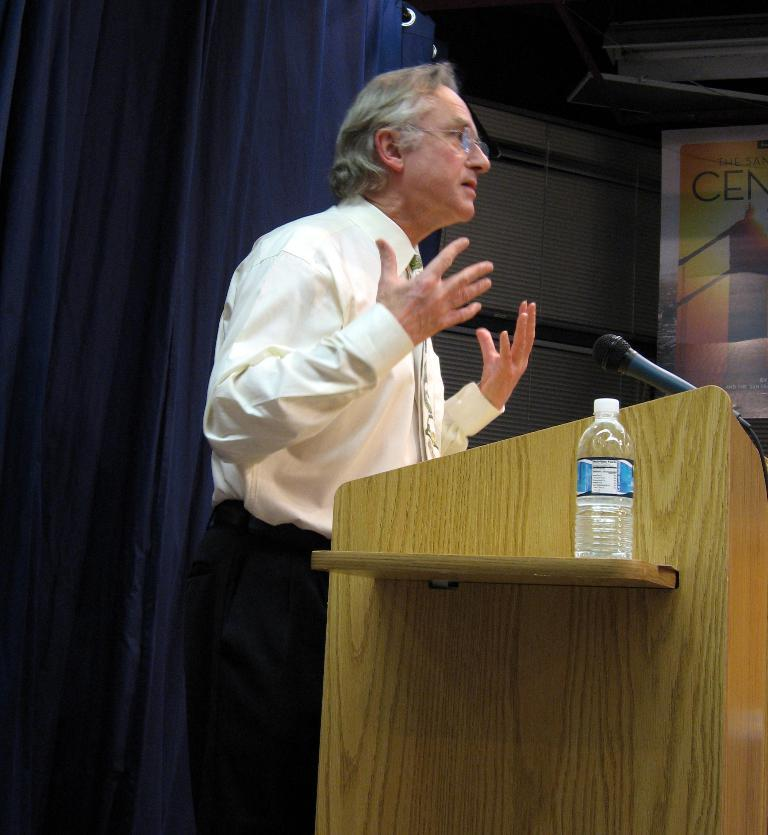What is the person in the image doing? The person is standing in front of a podium. What can be seen on the podium? There is a bottle visible on the podium. What is used for amplifying the person's voice in the image? There is a microphone (mic) in the image. What color is the curtain in the background? There is a blue color curtain in the background. What else can be seen in the background? There are objects present in the background. How does the hen interact with the person at the podium in the image? There is no hen present in the image, so it cannot interact with the person at the podium. 